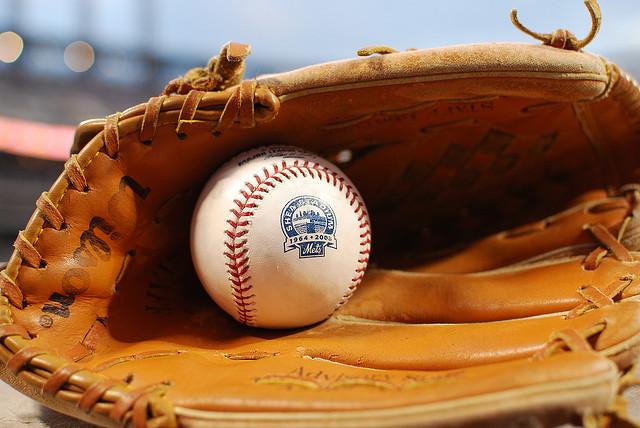What is inside the glove?
Quick response, please. Baseball. How big is the glove?
Keep it brief. Large. What is cast?
Write a very short answer. Baseball. What gem does remind you of?
Be succinct. Diamond. 